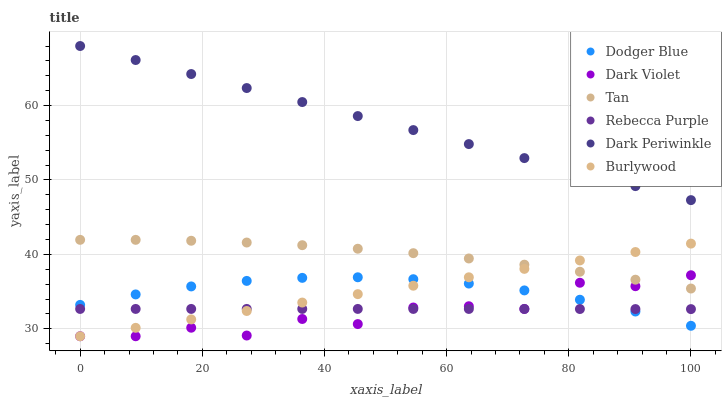Does Dark Violet have the minimum area under the curve?
Answer yes or no. Yes. Does Dark Periwinkle have the maximum area under the curve?
Answer yes or no. Yes. Does Dodger Blue have the minimum area under the curve?
Answer yes or no. No. Does Dodger Blue have the maximum area under the curve?
Answer yes or no. No. Is Burlywood the smoothest?
Answer yes or no. Yes. Is Dark Violet the roughest?
Answer yes or no. Yes. Is Dodger Blue the smoothest?
Answer yes or no. No. Is Dodger Blue the roughest?
Answer yes or no. No. Does Burlywood have the lowest value?
Answer yes or no. Yes. Does Dodger Blue have the lowest value?
Answer yes or no. No. Does Dark Periwinkle have the highest value?
Answer yes or no. Yes. Does Dark Violet have the highest value?
Answer yes or no. No. Is Rebecca Purple less than Tan?
Answer yes or no. Yes. Is Dark Periwinkle greater than Rebecca Purple?
Answer yes or no. Yes. Does Dodger Blue intersect Dark Violet?
Answer yes or no. Yes. Is Dodger Blue less than Dark Violet?
Answer yes or no. No. Is Dodger Blue greater than Dark Violet?
Answer yes or no. No. Does Rebecca Purple intersect Tan?
Answer yes or no. No. 